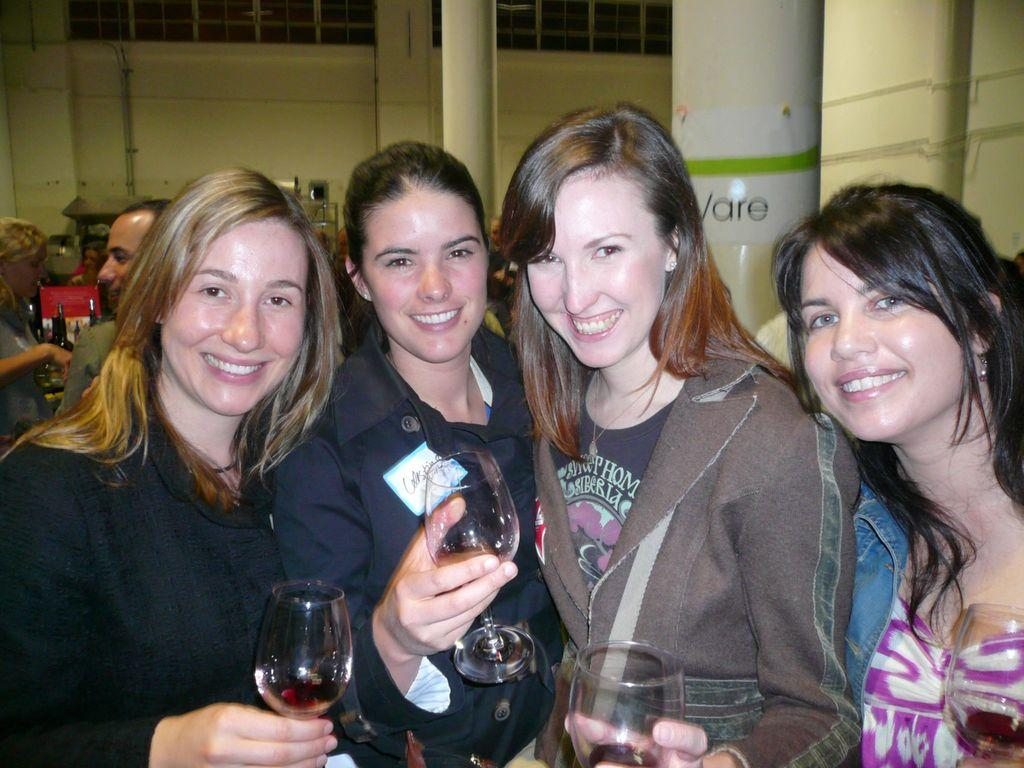How many women are in the image? There are four women in the image. What are the women doing in the image? The women are posing for the camera. What are the women holding in the image? Each woman is holding a wine glass. Can you describe the background of the image? There are people visible in the background of the image. What type of yak can be seen in the image? There is no yak present in the image. How many wrens are perched on the women's shoulders in the image? There are no wrens present in the image. 